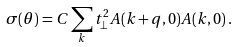Convert formula to latex. <formula><loc_0><loc_0><loc_500><loc_500>\sigma ( \theta ) = C \sum _ { k } t ^ { 2 } _ { \perp } A ( { k } + { q } , 0 ) A ( { k } , 0 ) \, .</formula> 